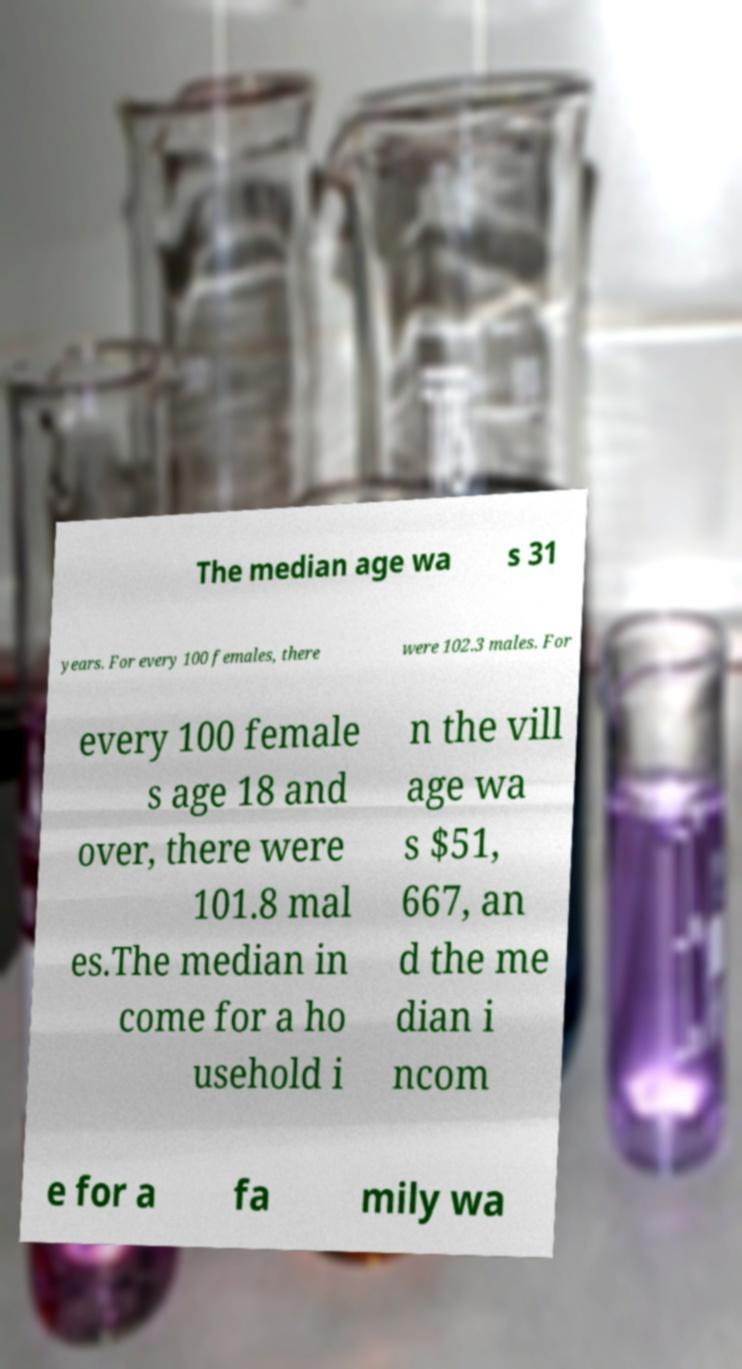I need the written content from this picture converted into text. Can you do that? The median age wa s 31 years. For every 100 females, there were 102.3 males. For every 100 female s age 18 and over, there were 101.8 mal es.The median in come for a ho usehold i n the vill age wa s $51, 667, an d the me dian i ncom e for a fa mily wa 